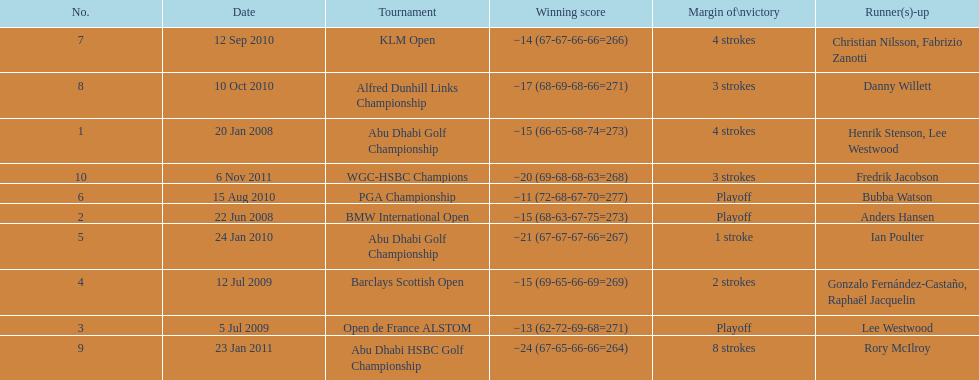Who had the top score in the pga championship? Bubba Watson. 